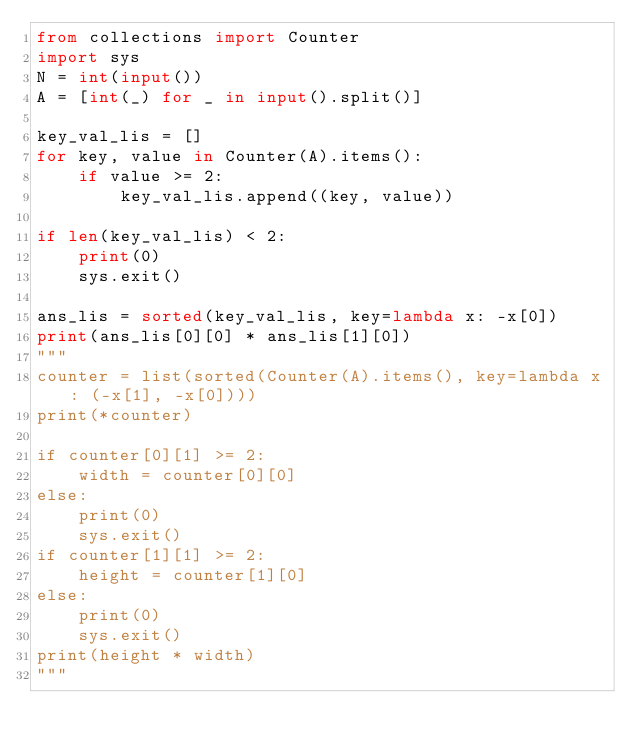Convert code to text. <code><loc_0><loc_0><loc_500><loc_500><_Python_>from collections import Counter
import sys
N = int(input())
A = [int(_) for _ in input().split()]

key_val_lis = []
for key, value in Counter(A).items():
    if value >= 2:
        key_val_lis.append((key, value))

if len(key_val_lis) < 2:
    print(0)
    sys.exit()

ans_lis = sorted(key_val_lis, key=lambda x: -x[0])
print(ans_lis[0][0] * ans_lis[1][0])
"""
counter = list(sorted(Counter(A).items(), key=lambda x: (-x[1], -x[0])))
print(*counter)

if counter[0][1] >= 2:
    width = counter[0][0]
else:
    print(0)
    sys.exit()
if counter[1][1] >= 2:
    height = counter[1][0]
else:
    print(0)
    sys.exit()
print(height * width)
"""
</code> 